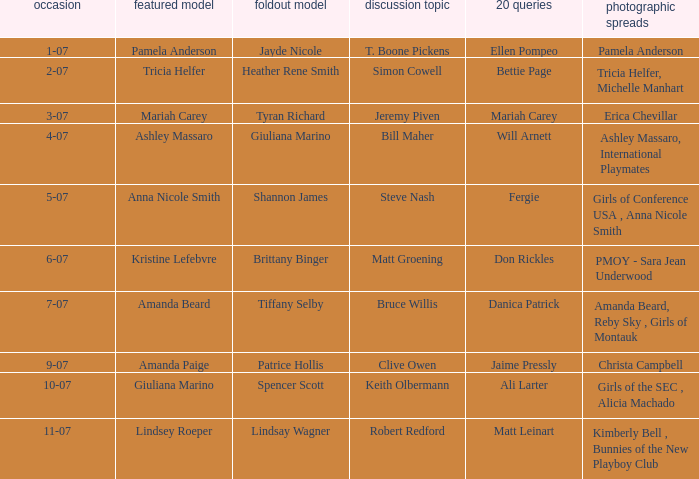Who was the centerfold model when the issue's pictorial was amanda beard, reby sky , girls of montauk ? Tiffany Selby. 